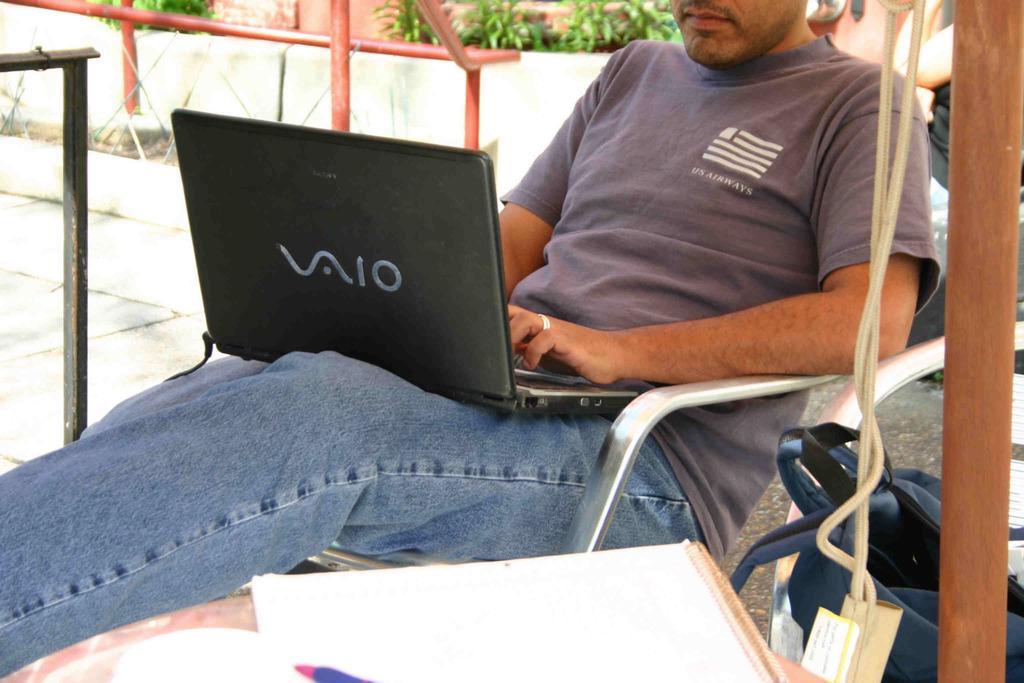Describe this image in one or two sentences. In this picture we can see a man sitting on a chair with a laptop on him, papers, pen, bag, rods, plants, floor and some objects. 